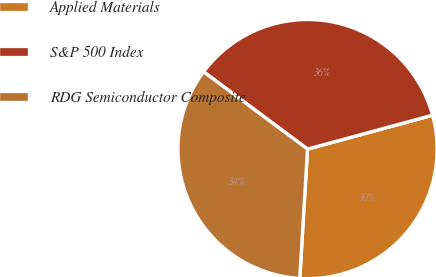Convert chart to OTSL. <chart><loc_0><loc_0><loc_500><loc_500><pie_chart><fcel>Applied Materials<fcel>S&P 500 Index<fcel>RDG Semiconductor Composite<nl><fcel>30.17%<fcel>35.61%<fcel>34.22%<nl></chart> 